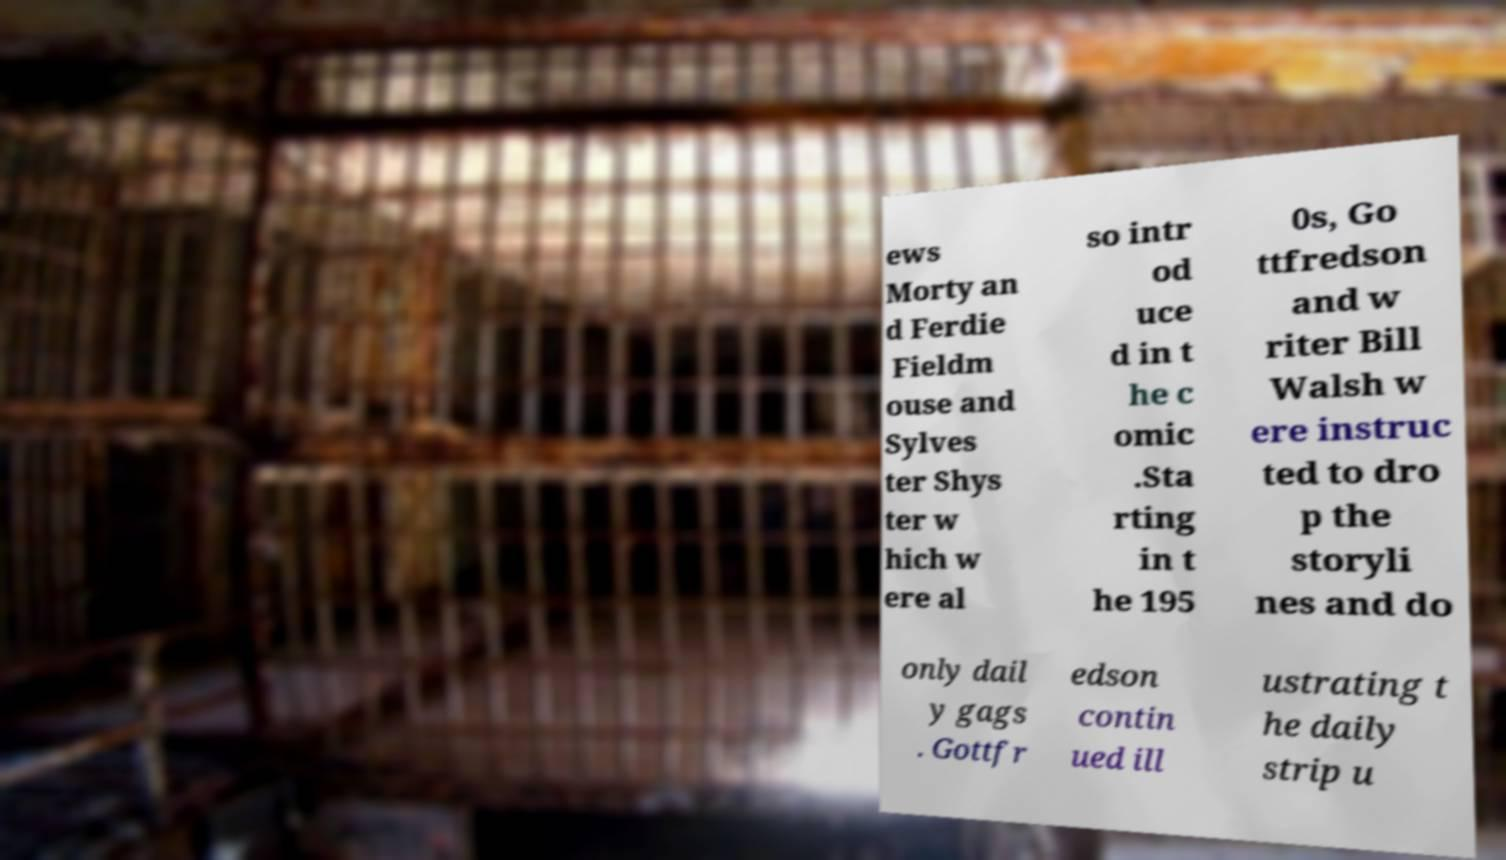Can you accurately transcribe the text from the provided image for me? ews Morty an d Ferdie Fieldm ouse and Sylves ter Shys ter w hich w ere al so intr od uce d in t he c omic .Sta rting in t he 195 0s, Go ttfredson and w riter Bill Walsh w ere instruc ted to dro p the storyli nes and do only dail y gags . Gottfr edson contin ued ill ustrating t he daily strip u 